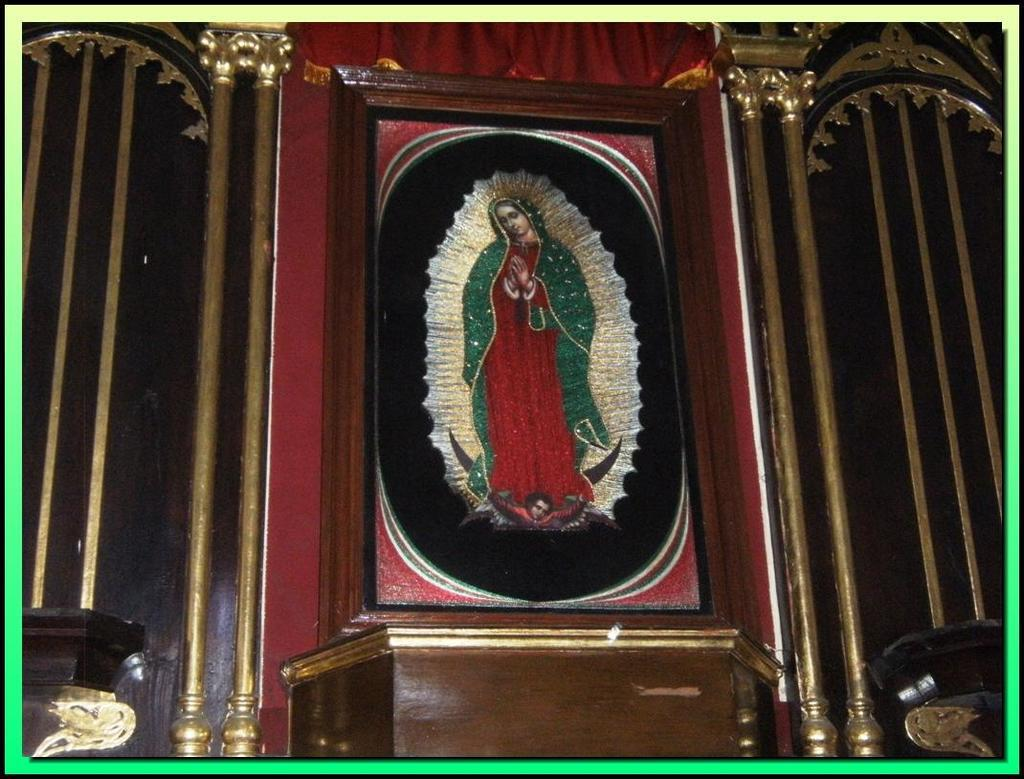What is depicted in the frame that is on the wall in the image? There is a frame of a person in the image. Where is the frame located in the image? The frame is on the wall in the image. What else can be seen on the wall in the image? There are poles and designs on the wall in the image. When did the horses start running in the image? There are no horses present in the image, so it is not possible to determine when they might have started running. 